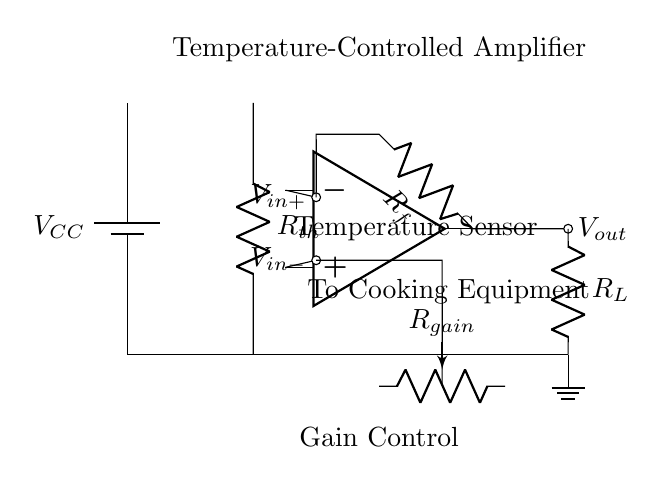What type of amplifier is depicted in the circuit? The circuit shows an operational amplifier, often used for precision tasks like signal modification. The symbol in the diagram is characteristic of operational amplifiers.
Answer: Operational amplifier What is the purpose of the temperature sensor? The temperature sensor, labeled as a thermistor (Rth), provides temperature feedback to the operational amplifier, which is crucial for maintaining precise cooking temperatures.
Answer: Temperature feedback What component offers gain adjustment in this circuit? The potentiometer labeled as Rgain allows for the adjustment of the gain, influencing the amplification level of the input signal.
Answer: Potentiometer What type of feedback configuration is present in this circuit? This circuit features a negative feedback configuration, as shown by the feedback resistor Rf connecting the output to the inverting input, which stabilizes and controls the gain.
Answer: Negative feedback How does the output affect the cooking equipment? The output voltage (Vout) can regulate the operation of the cooking equipment by adjusting the power supplied based on the temperature feedback, ensuring consistent cooking conditions.
Answer: Regulates cooking equipment 